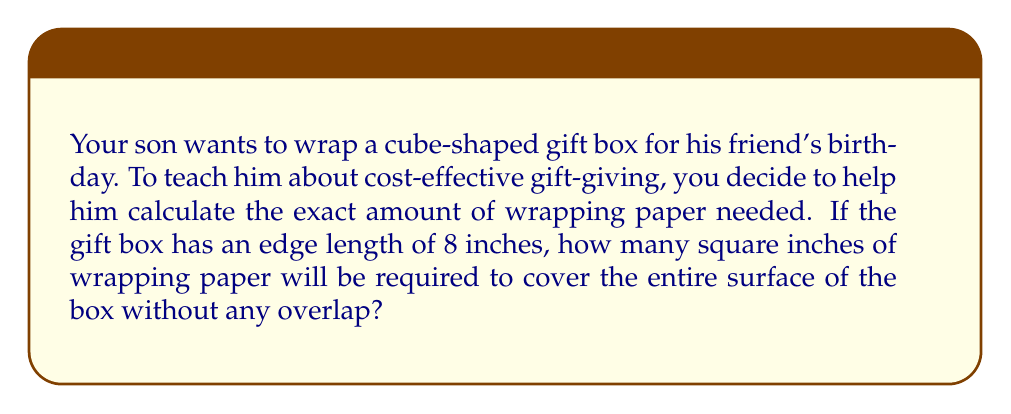Can you solve this math problem? Let's approach this step-by-step:

1) First, recall the formula for the surface area of a cube:
   $$SA = 6s^2$$
   where $SA$ is the surface area and $s$ is the length of an edge.

2) We're given that the edge length is 8 inches. Let's substitute this into our formula:
   $$SA = 6(8^2)$$

3) Now, let's calculate:
   $$SA = 6(64) = 384$$

4) Therefore, the total surface area is 384 square inches.

This calculation helps teach your son about:
- Practical application of geometry
- Planning ahead to avoid waste (by knowing exactly how much paper is needed)
- The importance of precise measurements in cost-effective practices

[asy]
import three;
size(200);
currentprojection=perspective(6,3,2);
draw(cube((0,0,0),(8,8,8)),blue);
label("8\"",(.5,0,0)--(8.5,0,0),S);
label("8\"",(.5,0,0)--(.5,8,0),W);
label("8\"",(.5,0,0)--(.5,0,8),NW);
[/asy]
Answer: 384 square inches 